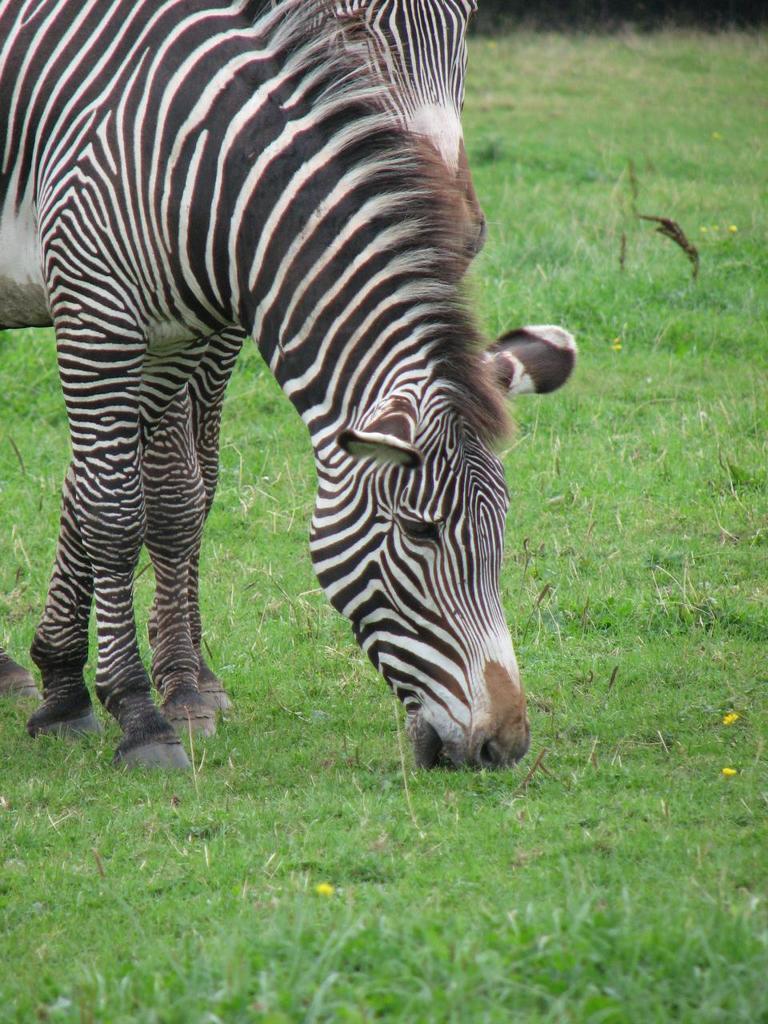In one or two sentences, can you explain what this image depicts? In this image there is a zebra on the surface of the grass. 